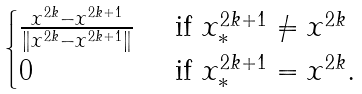Convert formula to latex. <formula><loc_0><loc_0><loc_500><loc_500>\begin{cases} \frac { x ^ { 2 k } - x ^ { 2 k + 1 } } { \| x ^ { 2 k } - x ^ { 2 k + 1 } \| } & \text { if } x _ { * } ^ { 2 k + 1 } \neq x ^ { 2 k } \\ 0 & \text { if } x _ { * } ^ { 2 k + 1 } = x ^ { 2 k } . \end{cases}</formula> 